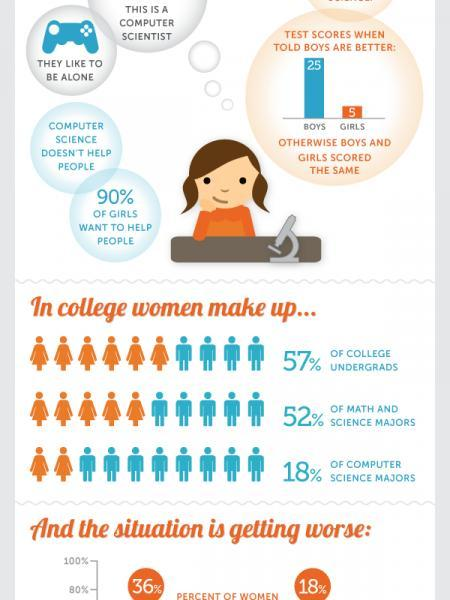What percentage of college students undergraduate are males?
Answer the question with a short phrase. 43 What percentage of girls don't want to help people? 10 what % of students who are doing computer science majors are males 82 What % of students who are doing math and science majors are males 48 